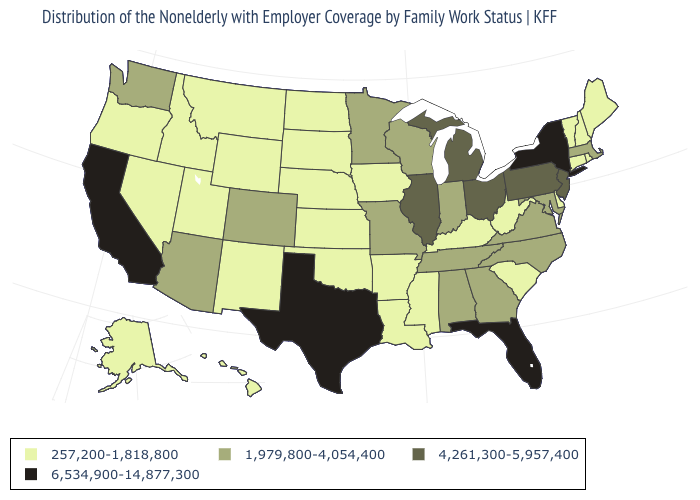What is the highest value in the MidWest ?
Keep it brief. 4,261,300-5,957,400. How many symbols are there in the legend?
Concise answer only. 4. Which states have the highest value in the USA?
Concise answer only. California, Florida, New York, Texas. Does Maine have the same value as Kentucky?
Keep it brief. Yes. Does Iowa have the highest value in the MidWest?
Answer briefly. No. Which states have the lowest value in the MidWest?
Answer briefly. Iowa, Kansas, Nebraska, North Dakota, South Dakota. Among the states that border South Dakota , which have the highest value?
Give a very brief answer. Minnesota. Name the states that have a value in the range 257,200-1,818,800?
Keep it brief. Alaska, Arkansas, Connecticut, Delaware, Hawaii, Idaho, Iowa, Kansas, Kentucky, Louisiana, Maine, Mississippi, Montana, Nebraska, Nevada, New Hampshire, New Mexico, North Dakota, Oklahoma, Oregon, Rhode Island, South Carolina, South Dakota, Utah, Vermont, West Virginia, Wyoming. How many symbols are there in the legend?
Be succinct. 4. Name the states that have a value in the range 257,200-1,818,800?
Be succinct. Alaska, Arkansas, Connecticut, Delaware, Hawaii, Idaho, Iowa, Kansas, Kentucky, Louisiana, Maine, Mississippi, Montana, Nebraska, Nevada, New Hampshire, New Mexico, North Dakota, Oklahoma, Oregon, Rhode Island, South Carolina, South Dakota, Utah, Vermont, West Virginia, Wyoming. Does Nevada have a lower value than Oregon?
Write a very short answer. No. What is the value of Oregon?
Quick response, please. 257,200-1,818,800. Name the states that have a value in the range 1,979,800-4,054,400?
Give a very brief answer. Alabama, Arizona, Colorado, Georgia, Indiana, Maryland, Massachusetts, Minnesota, Missouri, North Carolina, Tennessee, Virginia, Washington, Wisconsin. Does Kentucky have a lower value than Maryland?
Give a very brief answer. Yes. What is the lowest value in the Northeast?
Be succinct. 257,200-1,818,800. 